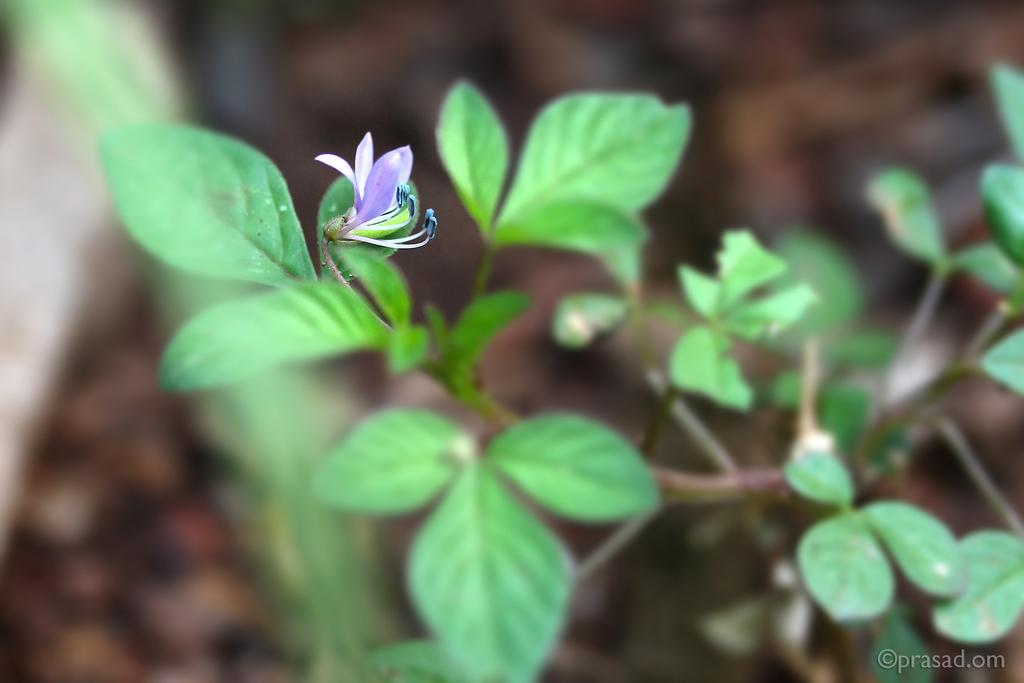What type of plant can be seen in the image? There is a flower plant in the image. Where is the flower plant located? The flower plant is on the land. What arithmetic problem is being solved by the geese in the image? There are no geese or arithmetic problems present in the image. 